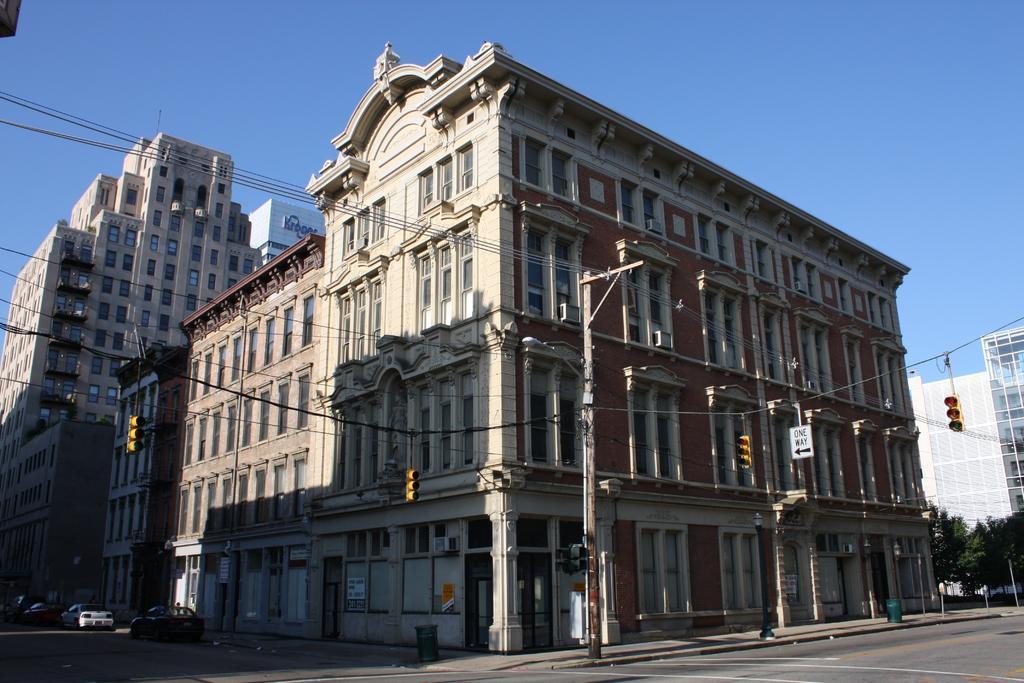Please provide a concise description of this image. In this picture we can see buildings, on the left side there are three cars parked, we can see poles and wires here, there is a sign board and traffic lights here, there is the sky at the top of the picture. 